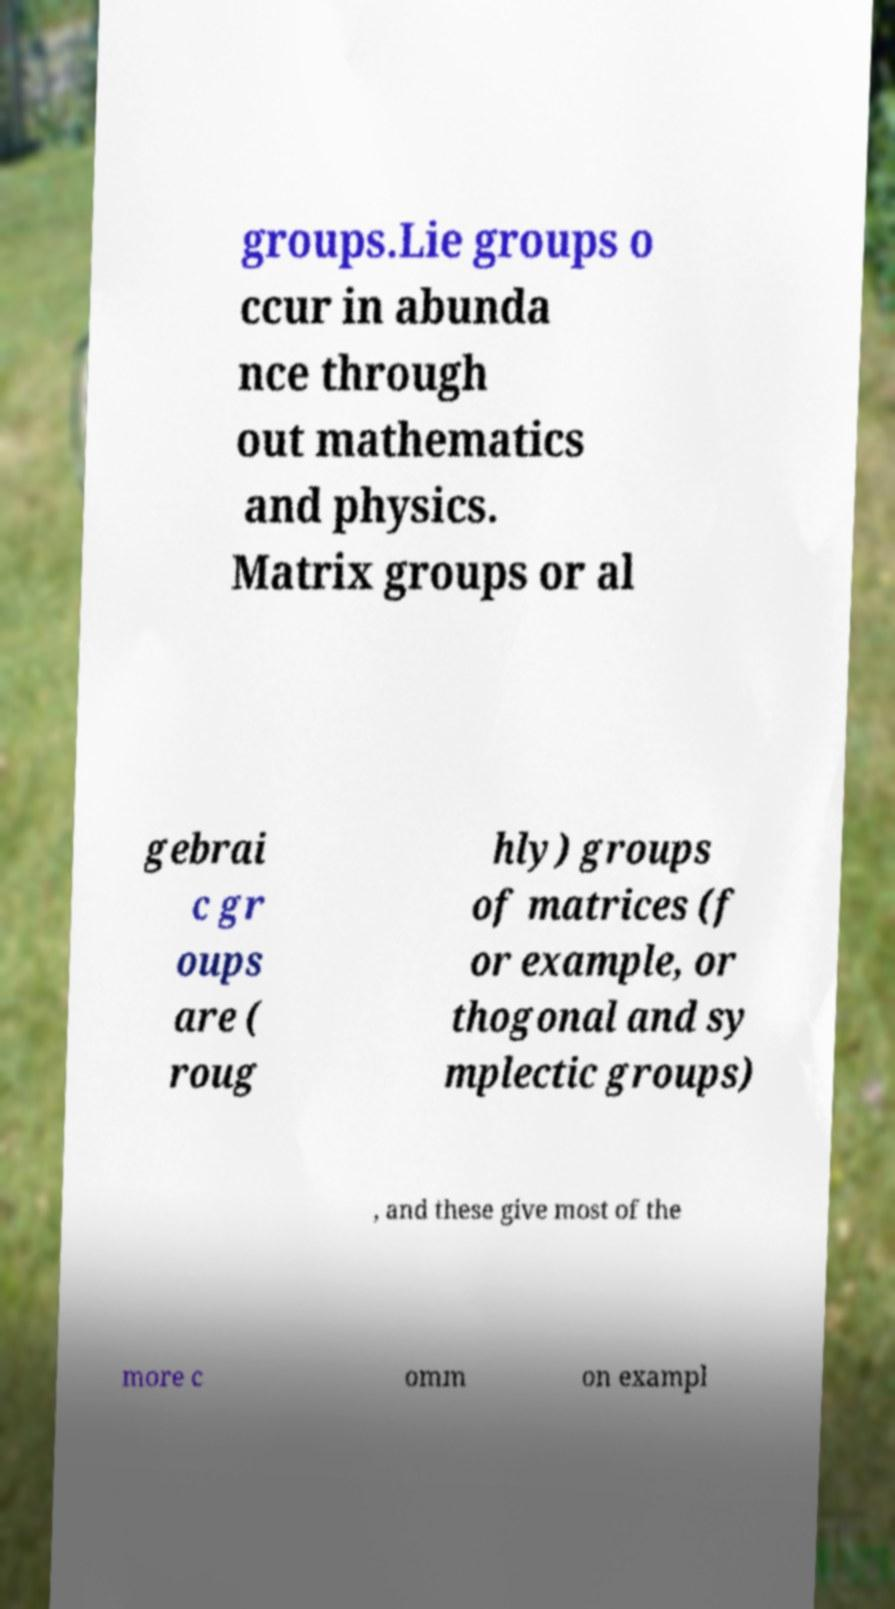Please identify and transcribe the text found in this image. groups.Lie groups o ccur in abunda nce through out mathematics and physics. Matrix groups or al gebrai c gr oups are ( roug hly) groups of matrices (f or example, or thogonal and sy mplectic groups) , and these give most of the more c omm on exampl 